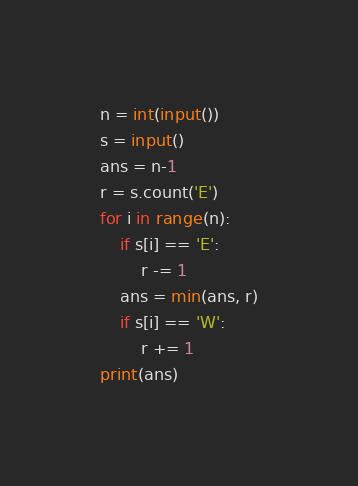Convert code to text. <code><loc_0><loc_0><loc_500><loc_500><_Python_>n = int(input())
s = input()
ans = n-1
r = s.count('E')
for i in range(n):
    if s[i] == 'E':
        r -= 1
    ans = min(ans, r)
    if s[i] == 'W':
        r += 1
print(ans)</code> 